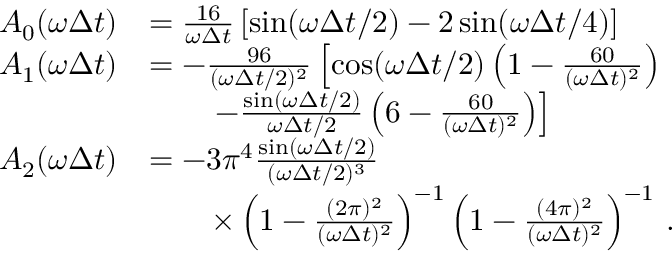<formula> <loc_0><loc_0><loc_500><loc_500>\begin{array} { r l } { A _ { 0 } ( \omega \Delta t ) } & { = \frac { 1 6 } { \omega \Delta t } \left [ \sin ( \omega \Delta t / 2 ) - 2 \sin ( \omega \Delta t / 4 ) \right ] } \\ { A _ { 1 } ( \omega \Delta t ) } & { = - \frac { 9 6 } { ( \omega \Delta t / 2 ) ^ { 2 } } \left [ \cos ( \omega \Delta t / 2 ) \left ( 1 - \frac { 6 0 } { ( \omega \Delta t ) ^ { 2 } } \right ) } \\ & { \quad - \frac { \sin ( \omega \Delta t / 2 ) } { \omega \Delta t / 2 } \left ( 6 - \frac { 6 0 } { ( \omega \Delta t ) ^ { 2 } } \right ) \right ] } \\ { A _ { 2 } ( \omega \Delta t ) } & { = - 3 \pi ^ { 4 } \frac { \sin ( \omega \Delta t / 2 ) } { ( \omega \Delta t / 2 ) ^ { 3 } } } \\ & { \quad \times \left ( 1 - \frac { ( 2 \pi ) ^ { 2 } } { ( \omega \Delta t ) ^ { 2 } } \right ) ^ { - 1 } \left ( 1 - \frac { ( 4 \pi ) ^ { 2 } } { ( \omega \Delta t ) ^ { 2 } } \right ) ^ { - 1 } \, . } \end{array}</formula> 